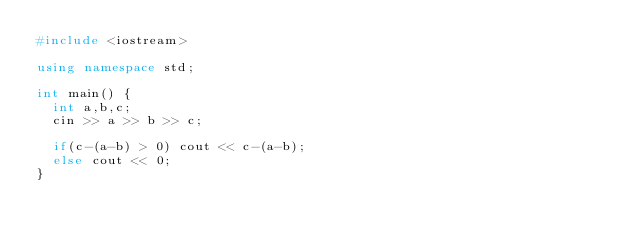Convert code to text. <code><loc_0><loc_0><loc_500><loc_500><_C++_>#include <iostream>

using namespace std;

int main() {
  int a,b,c;
  cin >> a >> b >> c;

  if(c-(a-b) > 0) cout << c-(a-b);
  else cout << 0;
}
</code> 